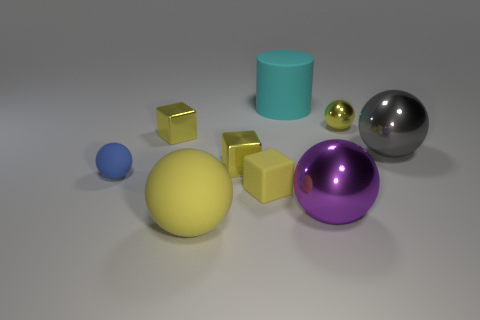Subtract all gray metal spheres. How many spheres are left? 4 Subtract all purple balls. How many balls are left? 4 Subtract all brown spheres. Subtract all gray blocks. How many spheres are left? 5 Add 1 gray spheres. How many objects exist? 10 Subtract all spheres. How many objects are left? 4 Add 1 gray things. How many gray things exist? 2 Subtract 1 cyan cylinders. How many objects are left? 8 Subtract all tiny rubber things. Subtract all green shiny objects. How many objects are left? 7 Add 7 metallic blocks. How many metallic blocks are left? 9 